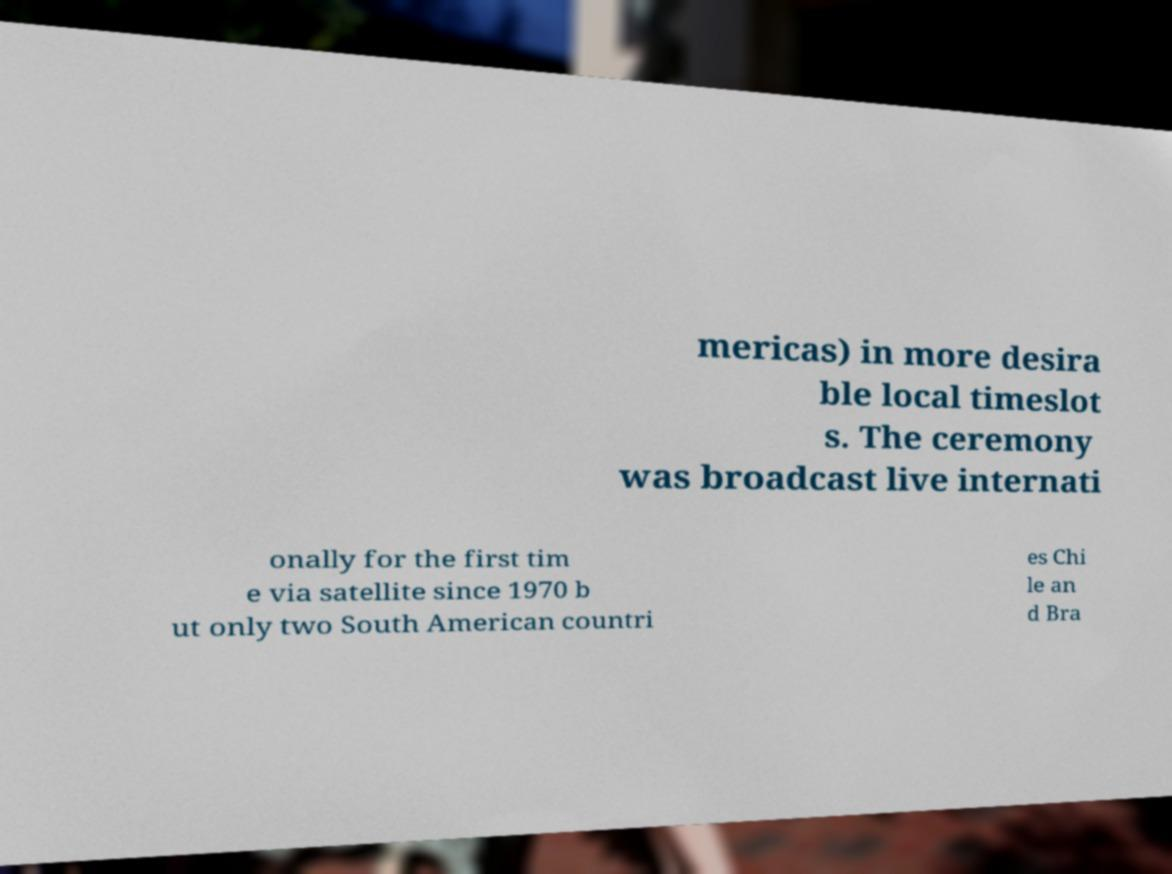There's text embedded in this image that I need extracted. Can you transcribe it verbatim? mericas) in more desira ble local timeslot s. The ceremony was broadcast live internati onally for the first tim e via satellite since 1970 b ut only two South American countri es Chi le an d Bra 